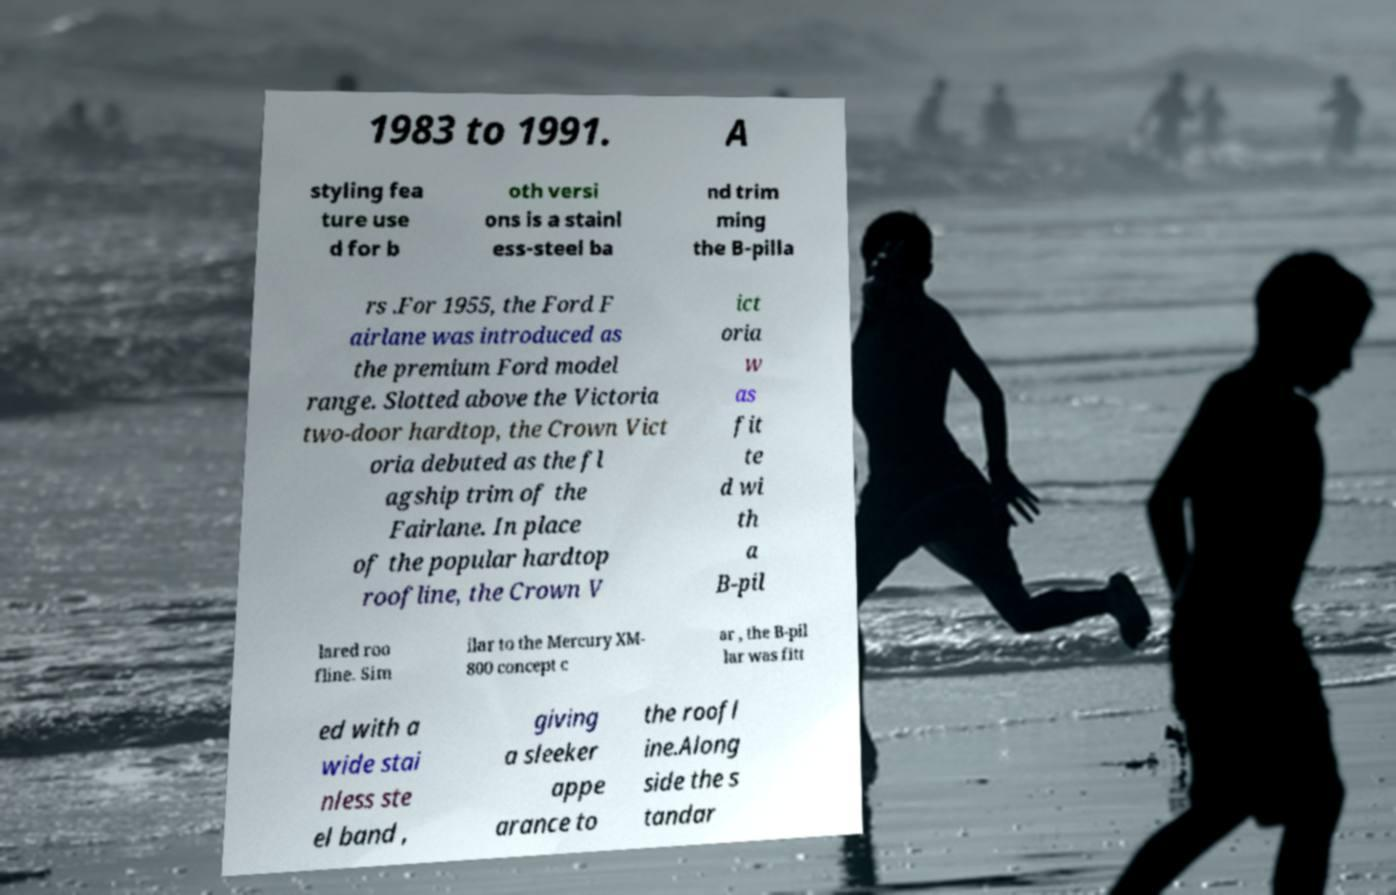What messages or text are displayed in this image? I need them in a readable, typed format. 1983 to 1991. A styling fea ture use d for b oth versi ons is a stainl ess-steel ba nd trim ming the B-pilla rs .For 1955, the Ford F airlane was introduced as the premium Ford model range. Slotted above the Victoria two-door hardtop, the Crown Vict oria debuted as the fl agship trim of the Fairlane. In place of the popular hardtop roofline, the Crown V ict oria w as fit te d wi th a B-pil lared roo fline. Sim ilar to the Mercury XM- 800 concept c ar , the B-pil lar was fitt ed with a wide stai nless ste el band , giving a sleeker appe arance to the roofl ine.Along side the s tandar 